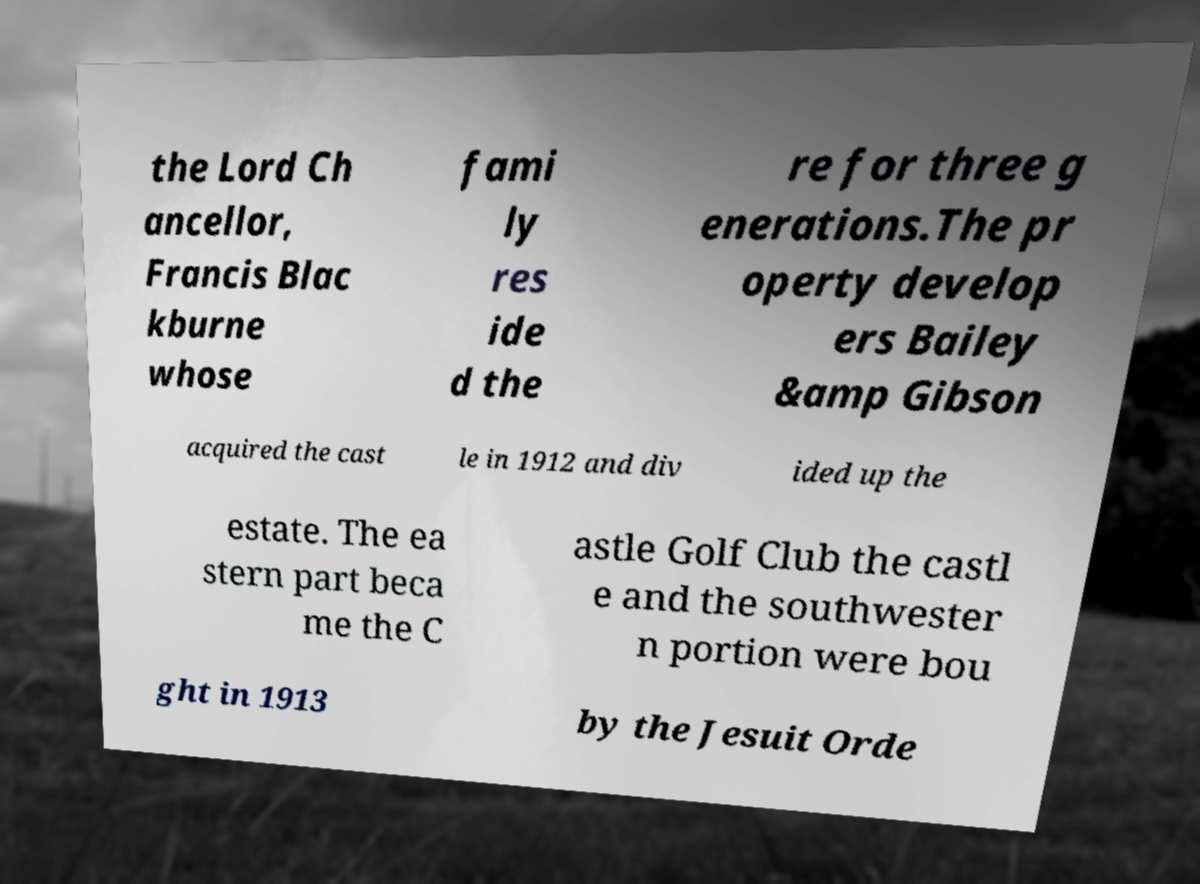I need the written content from this picture converted into text. Can you do that? the Lord Ch ancellor, Francis Blac kburne whose fami ly res ide d the re for three g enerations.The pr operty develop ers Bailey &amp Gibson acquired the cast le in 1912 and div ided up the estate. The ea stern part beca me the C astle Golf Club the castl e and the southwester n portion were bou ght in 1913 by the Jesuit Orde 